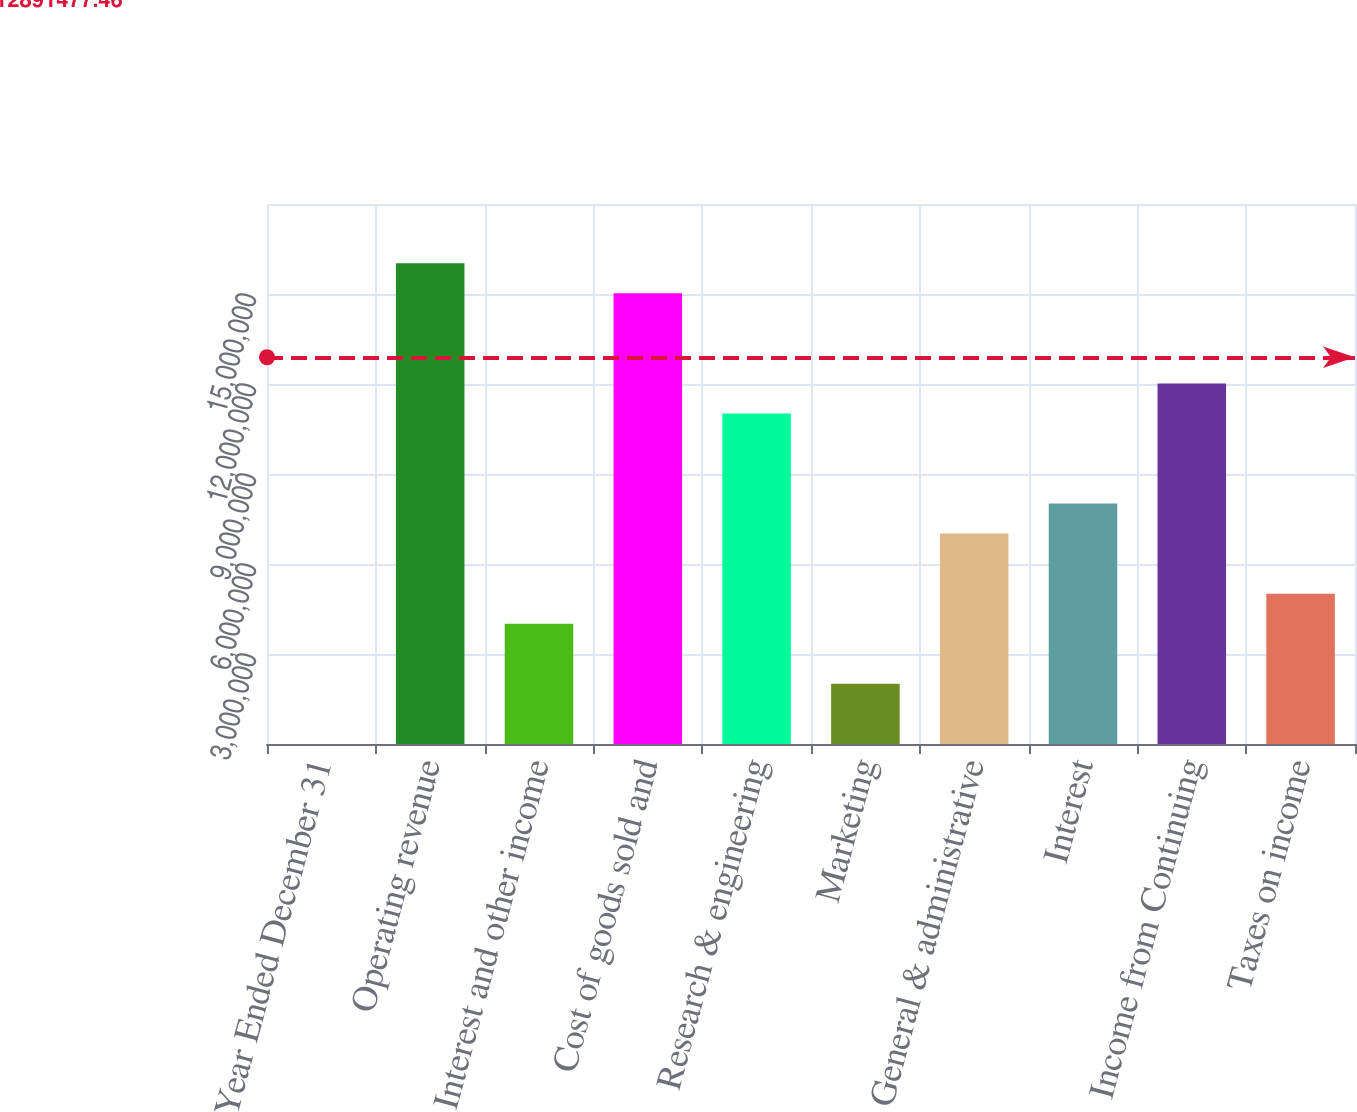Convert chart. <chart><loc_0><loc_0><loc_500><loc_500><bar_chart><fcel>Year Ended December 31<fcel>Operating revenue<fcel>Interest and other income<fcel>Cost of goods sold and<fcel>Research & engineering<fcel>Marketing<fcel>General & administrative<fcel>Interest<fcel>Income from Continuing<fcel>Taxes on income<nl><fcel>2003<fcel>1.60263e+07<fcel>4.00809e+06<fcel>1.50248e+07<fcel>1.10187e+07<fcel>2.00505e+06<fcel>7.01265e+06<fcel>8.01417e+06<fcel>1.20203e+07<fcel>5.00961e+06<nl></chart> 